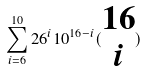<formula> <loc_0><loc_0><loc_500><loc_500>\sum _ { i = 6 } ^ { 1 0 } 2 6 ^ { i } 1 0 ^ { 1 6 - i } ( \begin{matrix} 1 6 \\ i \end{matrix} )</formula> 